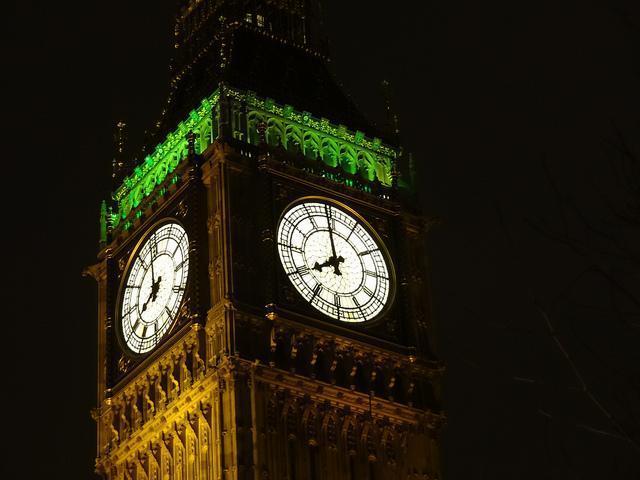How many clocks are in the picture?
Give a very brief answer. 2. 